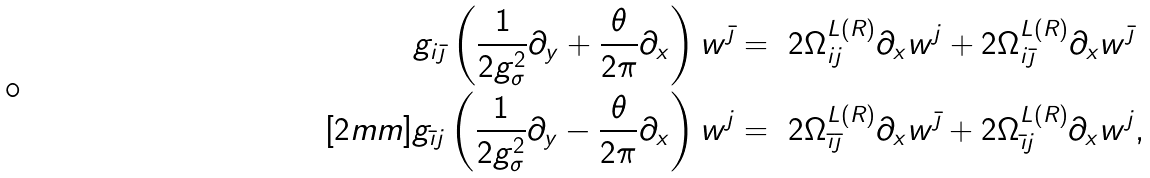<formula> <loc_0><loc_0><loc_500><loc_500>g _ { i \bar { \jmath } } \left ( \frac { 1 } { 2 g _ { \sigma } ^ { 2 } } \partial _ { y } + \frac { \theta } { 2 \pi } \partial _ { x } \right ) w ^ { \bar { \jmath } } & = \ 2 \Omega ^ { L ( R ) } _ { i j } \partial _ { x } w ^ { j } + 2 \Omega ^ { L ( R ) } _ { i \bar { \jmath } } \partial _ { x } w ^ { \bar { \jmath } } \\ [ 2 m m ] g _ { \bar { \imath } j } \left ( \frac { 1 } { 2 g _ { \sigma } ^ { 2 } } \partial _ { y } - \frac { \theta } { 2 \pi } \partial _ { x } \right ) w ^ { j } & = \ 2 \Omega ^ { L ( R ) } _ { \bar { \imath } \bar { \jmath } } \partial _ { x } w ^ { \bar { \jmath } } + 2 \Omega ^ { L ( R ) } _ { \bar { \imath } j } \partial _ { x } w ^ { j } ,</formula> 